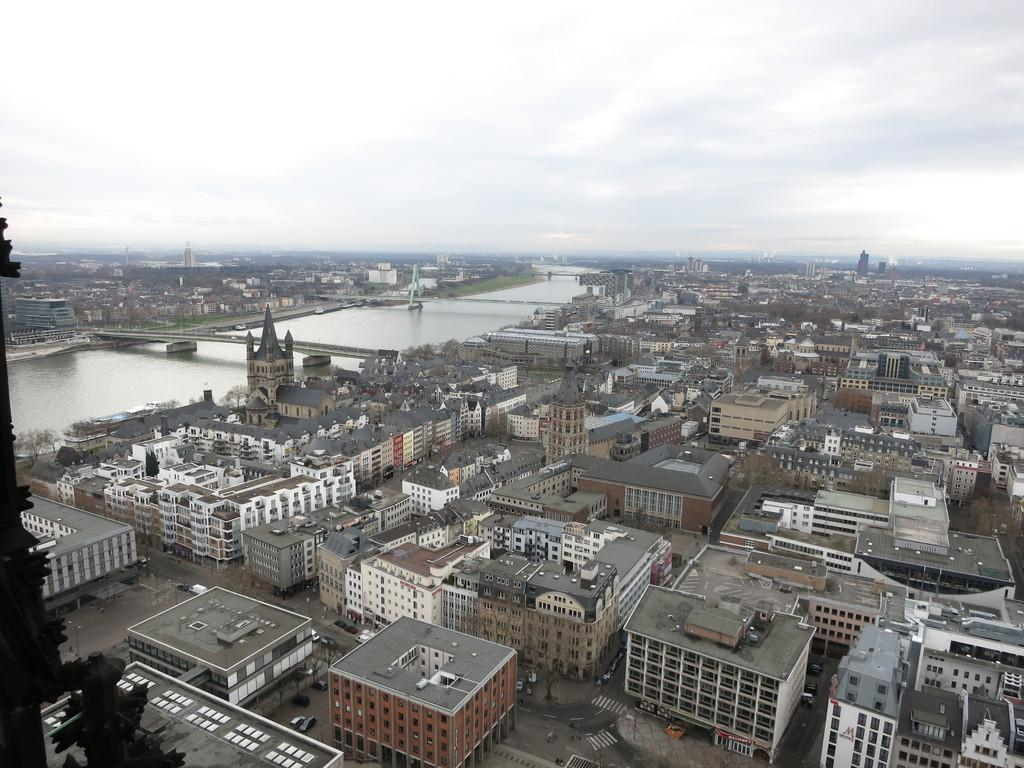What type of area is shown in the image? The image depicts an urban area. What structures can be seen in the image? There are buildings in the image. What mode of transportation is visible in the image? There are cars in the image. What type of infrastructure is present in the image? There are bridges in the image. How many books can be seen being read by people in the image? There is no indication of people reading books in the image. 